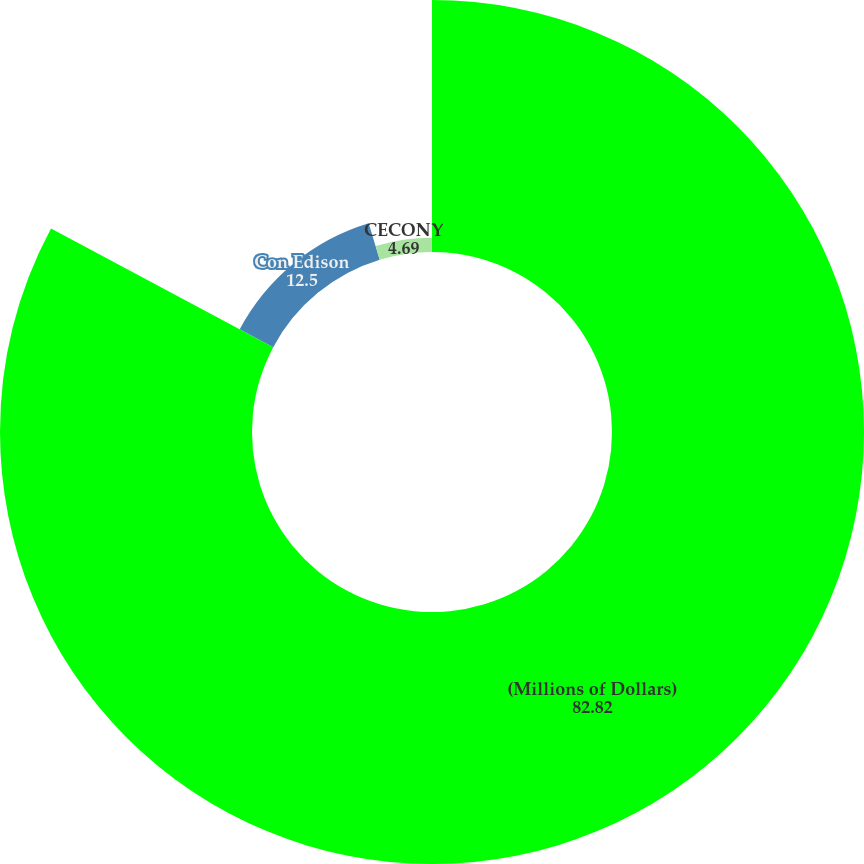Convert chart to OTSL. <chart><loc_0><loc_0><loc_500><loc_500><pie_chart><fcel>(Millions of Dollars)<fcel>Con Edison<fcel>CECONY<nl><fcel>82.82%<fcel>12.5%<fcel>4.69%<nl></chart> 